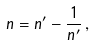Convert formula to latex. <formula><loc_0><loc_0><loc_500><loc_500>n = n ^ { \prime } - \frac { 1 } { n ^ { \prime } } \, ,</formula> 